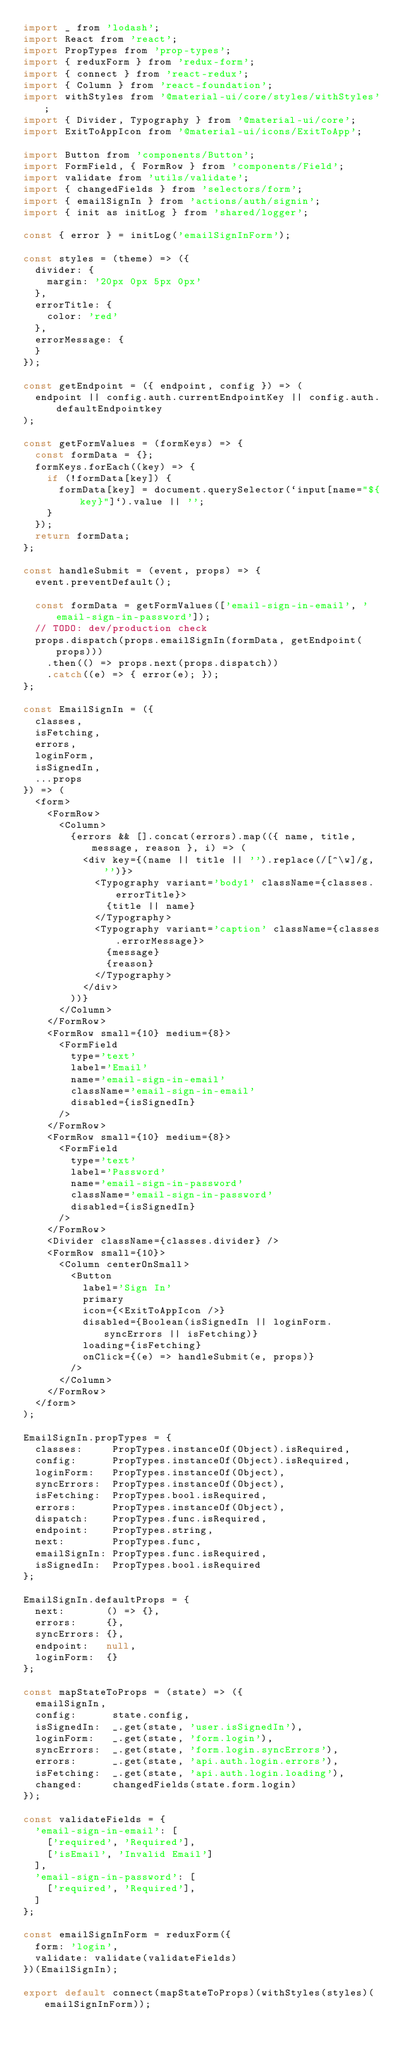Convert code to text. <code><loc_0><loc_0><loc_500><loc_500><_JavaScript_>import _ from 'lodash';
import React from 'react';
import PropTypes from 'prop-types';
import { reduxForm } from 'redux-form';
import { connect } from 'react-redux';
import { Column } from 'react-foundation';
import withStyles from '@material-ui/core/styles/withStyles';
import { Divider, Typography } from '@material-ui/core';
import ExitToAppIcon from '@material-ui/icons/ExitToApp';

import Button from 'components/Button';
import FormField, { FormRow } from 'components/Field';
import validate from 'utils/validate';
import { changedFields } from 'selectors/form';
import { emailSignIn } from 'actions/auth/signin';
import { init as initLog } from 'shared/logger';

const { error } = initLog('emailSignInForm');

const styles = (theme) => ({
  divider: {
    margin: '20px 0px 5px 0px'
  },
  errorTitle: {
    color: 'red'
  },
  errorMessage: {
  }
});

const getEndpoint = ({ endpoint, config }) => (
  endpoint || config.auth.currentEndpointKey || config.auth.defaultEndpointkey
);

const getFormValues = (formKeys) => {
  const formData = {};
  formKeys.forEach((key) => {
    if (!formData[key]) {
      formData[key] = document.querySelector(`input[name="${key}"]`).value || '';
    }
  });
  return formData;
};

const handleSubmit = (event, props) => {
  event.preventDefault();

  const formData = getFormValues(['email-sign-in-email', 'email-sign-in-password']);
  // TODO: dev/production check
  props.dispatch(props.emailSignIn(formData, getEndpoint(props)))
    .then(() => props.next(props.dispatch))
    .catch((e) => { error(e); });
};

const EmailSignIn = ({
  classes,
  isFetching,
  errors,
  loginForm,
  isSignedIn,
  ...props
}) => (
  <form>
    <FormRow>
      <Column>
        {errors && [].concat(errors).map(({ name, title, message, reason }, i) => (
          <div key={(name || title || '').replace(/[^\w]/g, '')}>
            <Typography variant='body1' className={classes.errorTitle}>
              {title || name}
            </Typography>
            <Typography variant='caption' className={classes.errorMessage}>
              {message}
              {reason}
            </Typography>
          </div>
        ))}
      </Column>
    </FormRow>
    <FormRow small={10} medium={8}>
      <FormField
        type='text'
        label='Email'
        name='email-sign-in-email'
        className='email-sign-in-email'
        disabled={isSignedIn}
      />
    </FormRow>
    <FormRow small={10} medium={8}>
      <FormField
        type='text'
        label='Password'
        name='email-sign-in-password'
        className='email-sign-in-password'
        disabled={isSignedIn}
      />
    </FormRow>
    <Divider className={classes.divider} />
    <FormRow small={10}>
      <Column centerOnSmall>
        <Button
          label='Sign In'
          primary
          icon={<ExitToAppIcon />}
          disabled={Boolean(isSignedIn || loginForm.syncErrors || isFetching)}
          loading={isFetching}
          onClick={(e) => handleSubmit(e, props)}
        />
      </Column>
    </FormRow>
  </form>
);

EmailSignIn.propTypes = {
  classes:     PropTypes.instanceOf(Object).isRequired,
  config:      PropTypes.instanceOf(Object).isRequired,
  loginForm:   PropTypes.instanceOf(Object),
  syncErrors:  PropTypes.instanceOf(Object),
  isFetching:  PropTypes.bool.isRequired,
  errors:      PropTypes.instanceOf(Object),
  dispatch:    PropTypes.func.isRequired,
  endpoint:    PropTypes.string,
  next:        PropTypes.func,
  emailSignIn: PropTypes.func.isRequired,
  isSignedIn:  PropTypes.bool.isRequired
};

EmailSignIn.defaultProps = {
  next:       () => {},
  errors:     {},
  syncErrors: {},
  endpoint:   null,
  loginForm:  {}
};

const mapStateToProps = (state) => ({
  emailSignIn,
  config:      state.config,
  isSignedIn:  _.get(state, 'user.isSignedIn'),
  loginForm:   _.get(state, 'form.login'),
  syncErrors:  _.get(state, 'form.login.syncErrors'),
  errors:      _.get(state, 'api.auth.login.errors'),
  isFetching:  _.get(state, 'api.auth.login.loading'),
  changed:     changedFields(state.form.login)
});

const validateFields = {
  'email-sign-in-email': [
    ['required', 'Required'],
    ['isEmail', 'Invalid Email']
  ],
  'email-sign-in-password': [
    ['required', 'Required'],
  ]
};

const emailSignInForm = reduxForm({
  form: 'login',
  validate: validate(validateFields)
})(EmailSignIn);

export default connect(mapStateToProps)(withStyles(styles)(emailSignInForm));
</code> 